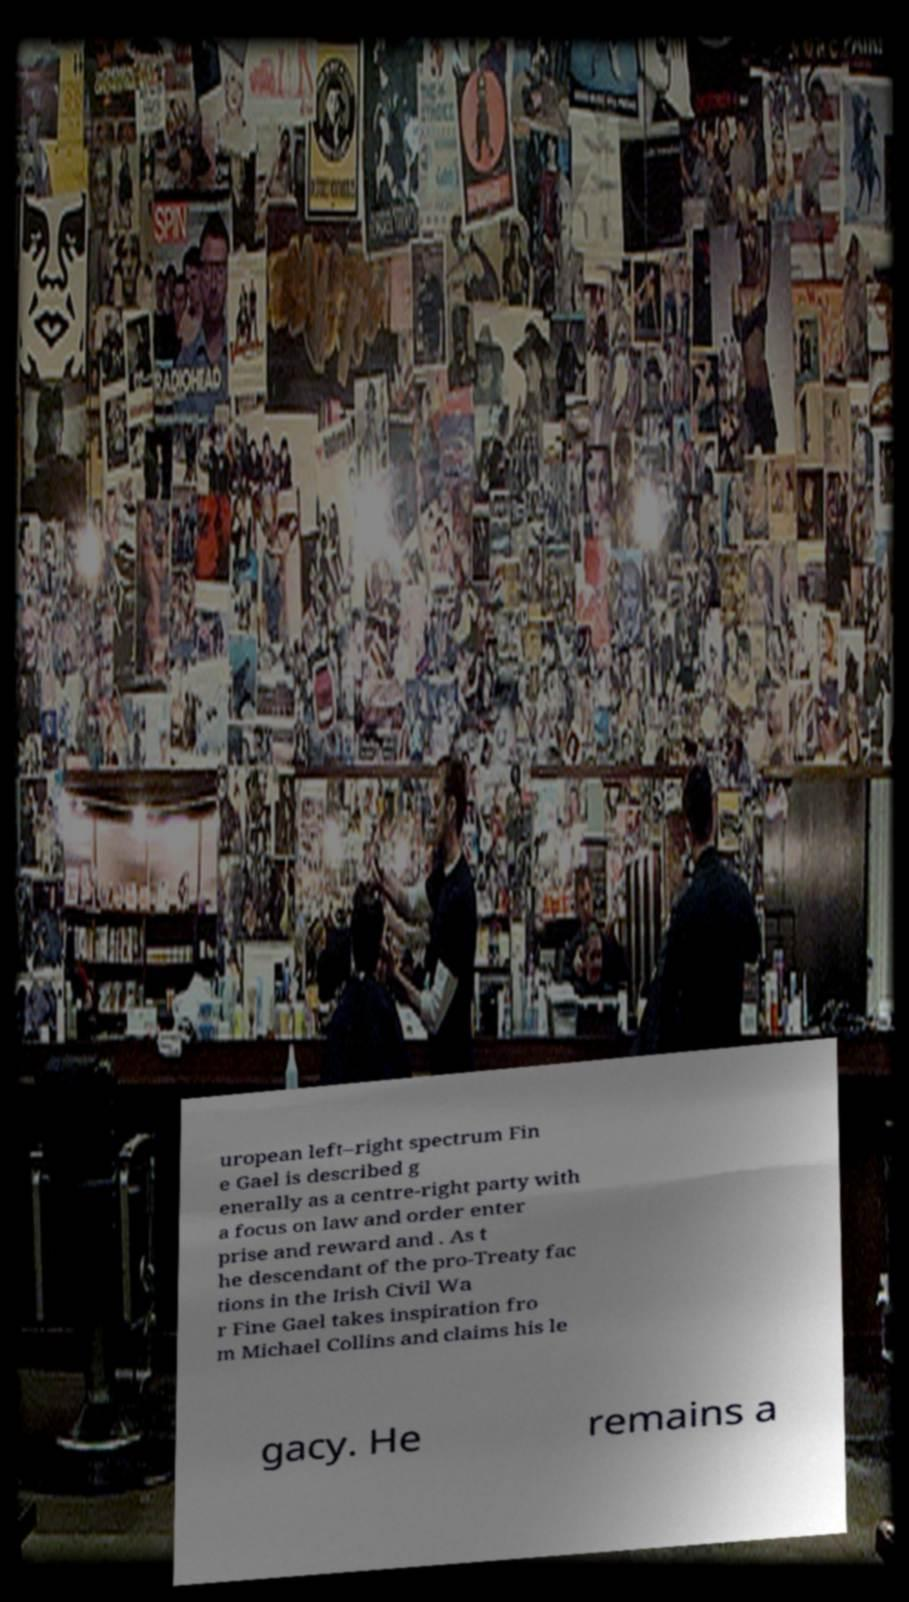I need the written content from this picture converted into text. Can you do that? uropean left–right spectrum Fin e Gael is described g enerally as a centre-right party with a focus on law and order enter prise and reward and . As t he descendant of the pro-Treaty fac tions in the Irish Civil Wa r Fine Gael takes inspiration fro m Michael Collins and claims his le gacy. He remains a 